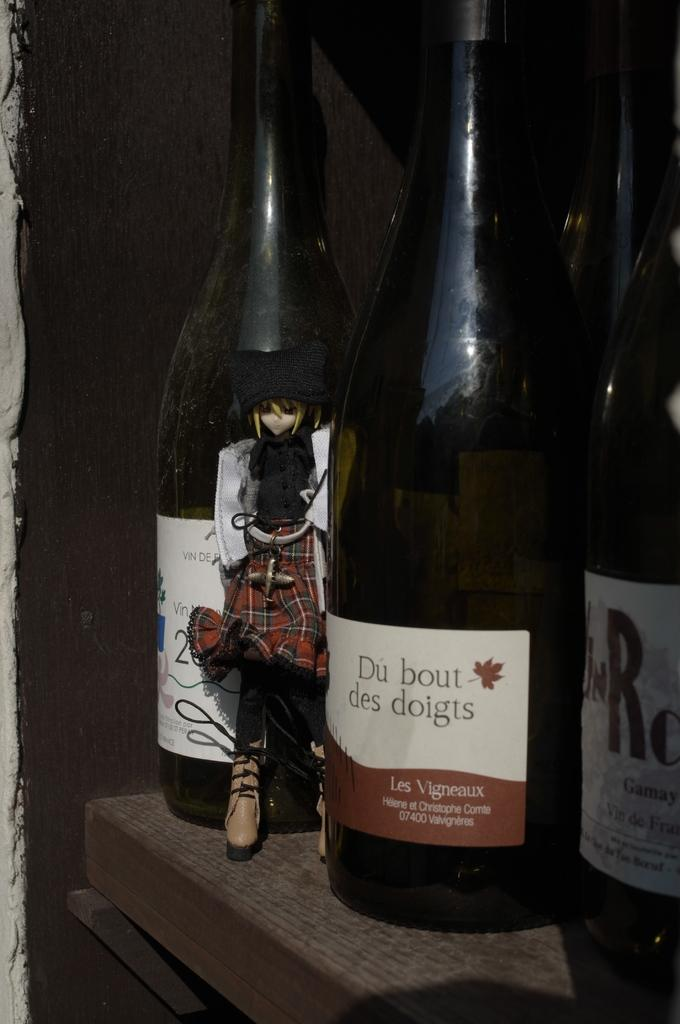<image>
Create a compact narrative representing the image presented. A bottle has a label with a leaf and says Du bout des doigts. 